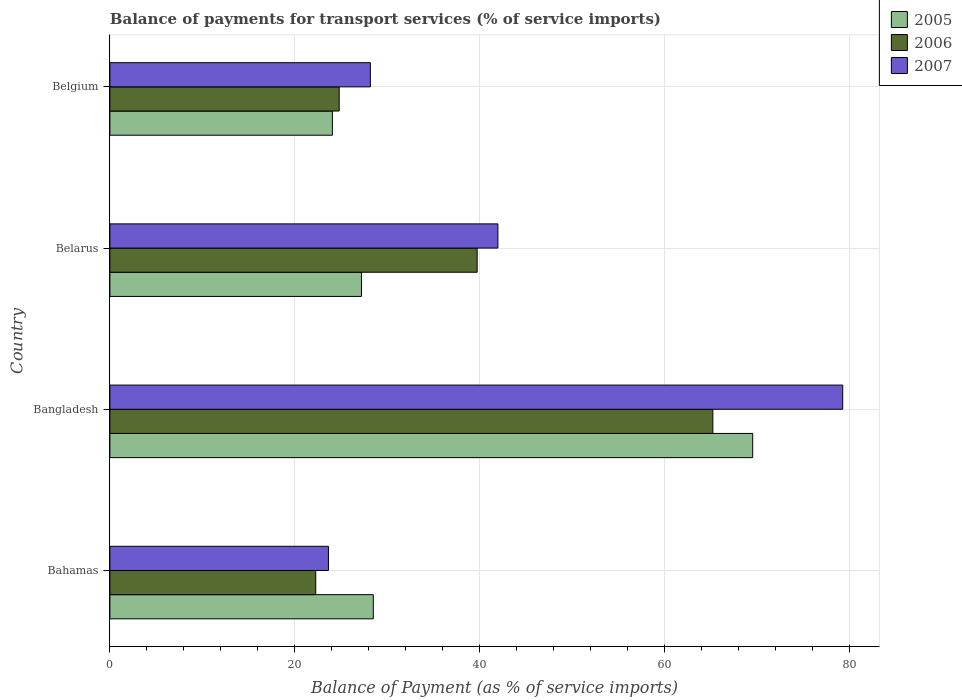How many different coloured bars are there?
Make the answer very short. 3. Are the number of bars per tick equal to the number of legend labels?
Your answer should be very brief. Yes. How many bars are there on the 2nd tick from the top?
Make the answer very short. 3. What is the label of the 4th group of bars from the top?
Keep it short and to the point. Bahamas. In how many cases, is the number of bars for a given country not equal to the number of legend labels?
Make the answer very short. 0. What is the balance of payments for transport services in 2006 in Bahamas?
Ensure brevity in your answer.  22.26. Across all countries, what is the maximum balance of payments for transport services in 2006?
Provide a succinct answer. 65.2. Across all countries, what is the minimum balance of payments for transport services in 2006?
Provide a succinct answer. 22.26. In which country was the balance of payments for transport services in 2005 maximum?
Provide a succinct answer. Bangladesh. In which country was the balance of payments for transport services in 2005 minimum?
Offer a very short reply. Belgium. What is the total balance of payments for transport services in 2007 in the graph?
Provide a short and direct response. 172.99. What is the difference between the balance of payments for transport services in 2006 in Bangladesh and that in Belarus?
Provide a succinct answer. 25.48. What is the difference between the balance of payments for transport services in 2005 in Bangladesh and the balance of payments for transport services in 2007 in Belarus?
Provide a succinct answer. 27.55. What is the average balance of payments for transport services in 2007 per country?
Make the answer very short. 43.25. What is the difference between the balance of payments for transport services in 2007 and balance of payments for transport services in 2006 in Belarus?
Give a very brief answer. 2.24. What is the ratio of the balance of payments for transport services in 2007 in Bahamas to that in Belarus?
Your response must be concise. 0.56. Is the difference between the balance of payments for transport services in 2007 in Belarus and Belgium greater than the difference between the balance of payments for transport services in 2006 in Belarus and Belgium?
Keep it short and to the point. No. What is the difference between the highest and the second highest balance of payments for transport services in 2005?
Ensure brevity in your answer.  41.02. What is the difference between the highest and the lowest balance of payments for transport services in 2006?
Your response must be concise. 42.94. Is the sum of the balance of payments for transport services in 2007 in Bahamas and Belarus greater than the maximum balance of payments for transport services in 2006 across all countries?
Provide a succinct answer. Yes. Is it the case that in every country, the sum of the balance of payments for transport services in 2005 and balance of payments for transport services in 2007 is greater than the balance of payments for transport services in 2006?
Make the answer very short. Yes. How many bars are there?
Your answer should be compact. 12. Are all the bars in the graph horizontal?
Offer a terse response. Yes. How many countries are there in the graph?
Offer a very short reply. 4. What is the difference between two consecutive major ticks on the X-axis?
Provide a short and direct response. 20. Are the values on the major ticks of X-axis written in scientific E-notation?
Keep it short and to the point. No. Does the graph contain any zero values?
Your response must be concise. No. Where does the legend appear in the graph?
Your response must be concise. Top right. How many legend labels are there?
Offer a terse response. 3. What is the title of the graph?
Your answer should be very brief. Balance of payments for transport services (% of service imports). What is the label or title of the X-axis?
Offer a terse response. Balance of Payment (as % of service imports). What is the Balance of Payment (as % of service imports) in 2005 in Bahamas?
Give a very brief answer. 28.48. What is the Balance of Payment (as % of service imports) in 2006 in Bahamas?
Make the answer very short. 22.26. What is the Balance of Payment (as % of service imports) of 2007 in Bahamas?
Your answer should be very brief. 23.63. What is the Balance of Payment (as % of service imports) of 2005 in Bangladesh?
Your answer should be compact. 69.5. What is the Balance of Payment (as % of service imports) in 2006 in Bangladesh?
Your answer should be very brief. 65.2. What is the Balance of Payment (as % of service imports) of 2007 in Bangladesh?
Your answer should be very brief. 79.24. What is the Balance of Payment (as % of service imports) of 2005 in Belarus?
Make the answer very short. 27.2. What is the Balance of Payment (as % of service imports) in 2006 in Belarus?
Ensure brevity in your answer.  39.71. What is the Balance of Payment (as % of service imports) of 2007 in Belarus?
Offer a very short reply. 41.96. What is the Balance of Payment (as % of service imports) in 2005 in Belgium?
Offer a very short reply. 24.06. What is the Balance of Payment (as % of service imports) in 2006 in Belgium?
Provide a short and direct response. 24.79. What is the Balance of Payment (as % of service imports) of 2007 in Belgium?
Your response must be concise. 28.16. Across all countries, what is the maximum Balance of Payment (as % of service imports) in 2005?
Your response must be concise. 69.5. Across all countries, what is the maximum Balance of Payment (as % of service imports) of 2006?
Your response must be concise. 65.2. Across all countries, what is the maximum Balance of Payment (as % of service imports) in 2007?
Give a very brief answer. 79.24. Across all countries, what is the minimum Balance of Payment (as % of service imports) in 2005?
Ensure brevity in your answer.  24.06. Across all countries, what is the minimum Balance of Payment (as % of service imports) of 2006?
Make the answer very short. 22.26. Across all countries, what is the minimum Balance of Payment (as % of service imports) of 2007?
Offer a very short reply. 23.63. What is the total Balance of Payment (as % of service imports) of 2005 in the graph?
Offer a very short reply. 149.25. What is the total Balance of Payment (as % of service imports) of 2006 in the graph?
Ensure brevity in your answer.  151.96. What is the total Balance of Payment (as % of service imports) of 2007 in the graph?
Offer a terse response. 172.99. What is the difference between the Balance of Payment (as % of service imports) of 2005 in Bahamas and that in Bangladesh?
Provide a succinct answer. -41.02. What is the difference between the Balance of Payment (as % of service imports) in 2006 in Bahamas and that in Bangladesh?
Offer a very short reply. -42.94. What is the difference between the Balance of Payment (as % of service imports) in 2007 in Bahamas and that in Bangladesh?
Your answer should be very brief. -55.61. What is the difference between the Balance of Payment (as % of service imports) in 2005 in Bahamas and that in Belarus?
Keep it short and to the point. 1.28. What is the difference between the Balance of Payment (as % of service imports) in 2006 in Bahamas and that in Belarus?
Your response must be concise. -17.45. What is the difference between the Balance of Payment (as % of service imports) of 2007 in Bahamas and that in Belarus?
Offer a terse response. -18.32. What is the difference between the Balance of Payment (as % of service imports) in 2005 in Bahamas and that in Belgium?
Give a very brief answer. 4.42. What is the difference between the Balance of Payment (as % of service imports) in 2006 in Bahamas and that in Belgium?
Your answer should be very brief. -2.54. What is the difference between the Balance of Payment (as % of service imports) of 2007 in Bahamas and that in Belgium?
Keep it short and to the point. -4.53. What is the difference between the Balance of Payment (as % of service imports) in 2005 in Bangladesh and that in Belarus?
Your answer should be very brief. 42.3. What is the difference between the Balance of Payment (as % of service imports) of 2006 in Bangladesh and that in Belarus?
Give a very brief answer. 25.48. What is the difference between the Balance of Payment (as % of service imports) of 2007 in Bangladesh and that in Belarus?
Provide a succinct answer. 37.28. What is the difference between the Balance of Payment (as % of service imports) in 2005 in Bangladesh and that in Belgium?
Give a very brief answer. 45.45. What is the difference between the Balance of Payment (as % of service imports) in 2006 in Bangladesh and that in Belgium?
Your response must be concise. 40.4. What is the difference between the Balance of Payment (as % of service imports) of 2007 in Bangladesh and that in Belgium?
Keep it short and to the point. 51.08. What is the difference between the Balance of Payment (as % of service imports) of 2005 in Belarus and that in Belgium?
Offer a terse response. 3.15. What is the difference between the Balance of Payment (as % of service imports) of 2006 in Belarus and that in Belgium?
Offer a terse response. 14.92. What is the difference between the Balance of Payment (as % of service imports) of 2007 in Belarus and that in Belgium?
Offer a terse response. 13.79. What is the difference between the Balance of Payment (as % of service imports) in 2005 in Bahamas and the Balance of Payment (as % of service imports) in 2006 in Bangladesh?
Your answer should be very brief. -36.71. What is the difference between the Balance of Payment (as % of service imports) in 2005 in Bahamas and the Balance of Payment (as % of service imports) in 2007 in Bangladesh?
Your response must be concise. -50.76. What is the difference between the Balance of Payment (as % of service imports) of 2006 in Bahamas and the Balance of Payment (as % of service imports) of 2007 in Bangladesh?
Your answer should be very brief. -56.98. What is the difference between the Balance of Payment (as % of service imports) of 2005 in Bahamas and the Balance of Payment (as % of service imports) of 2006 in Belarus?
Your response must be concise. -11.23. What is the difference between the Balance of Payment (as % of service imports) in 2005 in Bahamas and the Balance of Payment (as % of service imports) in 2007 in Belarus?
Your response must be concise. -13.47. What is the difference between the Balance of Payment (as % of service imports) in 2006 in Bahamas and the Balance of Payment (as % of service imports) in 2007 in Belarus?
Provide a succinct answer. -19.7. What is the difference between the Balance of Payment (as % of service imports) of 2005 in Bahamas and the Balance of Payment (as % of service imports) of 2006 in Belgium?
Keep it short and to the point. 3.69. What is the difference between the Balance of Payment (as % of service imports) of 2005 in Bahamas and the Balance of Payment (as % of service imports) of 2007 in Belgium?
Provide a short and direct response. 0.32. What is the difference between the Balance of Payment (as % of service imports) of 2006 in Bahamas and the Balance of Payment (as % of service imports) of 2007 in Belgium?
Provide a short and direct response. -5.91. What is the difference between the Balance of Payment (as % of service imports) of 2005 in Bangladesh and the Balance of Payment (as % of service imports) of 2006 in Belarus?
Keep it short and to the point. 29.79. What is the difference between the Balance of Payment (as % of service imports) of 2005 in Bangladesh and the Balance of Payment (as % of service imports) of 2007 in Belarus?
Give a very brief answer. 27.55. What is the difference between the Balance of Payment (as % of service imports) in 2006 in Bangladesh and the Balance of Payment (as % of service imports) in 2007 in Belarus?
Make the answer very short. 23.24. What is the difference between the Balance of Payment (as % of service imports) in 2005 in Bangladesh and the Balance of Payment (as % of service imports) in 2006 in Belgium?
Your answer should be very brief. 44.71. What is the difference between the Balance of Payment (as % of service imports) in 2005 in Bangladesh and the Balance of Payment (as % of service imports) in 2007 in Belgium?
Your answer should be compact. 41.34. What is the difference between the Balance of Payment (as % of service imports) of 2006 in Bangladesh and the Balance of Payment (as % of service imports) of 2007 in Belgium?
Keep it short and to the point. 37.03. What is the difference between the Balance of Payment (as % of service imports) of 2005 in Belarus and the Balance of Payment (as % of service imports) of 2006 in Belgium?
Your response must be concise. 2.41. What is the difference between the Balance of Payment (as % of service imports) in 2005 in Belarus and the Balance of Payment (as % of service imports) in 2007 in Belgium?
Make the answer very short. -0.96. What is the difference between the Balance of Payment (as % of service imports) in 2006 in Belarus and the Balance of Payment (as % of service imports) in 2007 in Belgium?
Offer a very short reply. 11.55. What is the average Balance of Payment (as % of service imports) in 2005 per country?
Keep it short and to the point. 37.31. What is the average Balance of Payment (as % of service imports) in 2006 per country?
Give a very brief answer. 37.99. What is the average Balance of Payment (as % of service imports) in 2007 per country?
Make the answer very short. 43.25. What is the difference between the Balance of Payment (as % of service imports) of 2005 and Balance of Payment (as % of service imports) of 2006 in Bahamas?
Offer a very short reply. 6.22. What is the difference between the Balance of Payment (as % of service imports) of 2005 and Balance of Payment (as % of service imports) of 2007 in Bahamas?
Ensure brevity in your answer.  4.85. What is the difference between the Balance of Payment (as % of service imports) of 2006 and Balance of Payment (as % of service imports) of 2007 in Bahamas?
Provide a succinct answer. -1.37. What is the difference between the Balance of Payment (as % of service imports) in 2005 and Balance of Payment (as % of service imports) in 2006 in Bangladesh?
Offer a terse response. 4.31. What is the difference between the Balance of Payment (as % of service imports) in 2005 and Balance of Payment (as % of service imports) in 2007 in Bangladesh?
Offer a terse response. -9.74. What is the difference between the Balance of Payment (as % of service imports) of 2006 and Balance of Payment (as % of service imports) of 2007 in Bangladesh?
Give a very brief answer. -14.04. What is the difference between the Balance of Payment (as % of service imports) in 2005 and Balance of Payment (as % of service imports) in 2006 in Belarus?
Keep it short and to the point. -12.51. What is the difference between the Balance of Payment (as % of service imports) in 2005 and Balance of Payment (as % of service imports) in 2007 in Belarus?
Your answer should be very brief. -14.75. What is the difference between the Balance of Payment (as % of service imports) of 2006 and Balance of Payment (as % of service imports) of 2007 in Belarus?
Provide a short and direct response. -2.24. What is the difference between the Balance of Payment (as % of service imports) of 2005 and Balance of Payment (as % of service imports) of 2006 in Belgium?
Your answer should be compact. -0.74. What is the difference between the Balance of Payment (as % of service imports) of 2005 and Balance of Payment (as % of service imports) of 2007 in Belgium?
Give a very brief answer. -4.11. What is the difference between the Balance of Payment (as % of service imports) in 2006 and Balance of Payment (as % of service imports) in 2007 in Belgium?
Your answer should be compact. -3.37. What is the ratio of the Balance of Payment (as % of service imports) in 2005 in Bahamas to that in Bangladesh?
Make the answer very short. 0.41. What is the ratio of the Balance of Payment (as % of service imports) in 2006 in Bahamas to that in Bangladesh?
Provide a short and direct response. 0.34. What is the ratio of the Balance of Payment (as % of service imports) in 2007 in Bahamas to that in Bangladesh?
Your response must be concise. 0.3. What is the ratio of the Balance of Payment (as % of service imports) in 2005 in Bahamas to that in Belarus?
Your answer should be very brief. 1.05. What is the ratio of the Balance of Payment (as % of service imports) of 2006 in Bahamas to that in Belarus?
Keep it short and to the point. 0.56. What is the ratio of the Balance of Payment (as % of service imports) of 2007 in Bahamas to that in Belarus?
Your answer should be very brief. 0.56. What is the ratio of the Balance of Payment (as % of service imports) of 2005 in Bahamas to that in Belgium?
Give a very brief answer. 1.18. What is the ratio of the Balance of Payment (as % of service imports) of 2006 in Bahamas to that in Belgium?
Your answer should be very brief. 0.9. What is the ratio of the Balance of Payment (as % of service imports) in 2007 in Bahamas to that in Belgium?
Keep it short and to the point. 0.84. What is the ratio of the Balance of Payment (as % of service imports) in 2005 in Bangladesh to that in Belarus?
Your answer should be compact. 2.55. What is the ratio of the Balance of Payment (as % of service imports) in 2006 in Bangladesh to that in Belarus?
Keep it short and to the point. 1.64. What is the ratio of the Balance of Payment (as % of service imports) of 2007 in Bangladesh to that in Belarus?
Your answer should be compact. 1.89. What is the ratio of the Balance of Payment (as % of service imports) of 2005 in Bangladesh to that in Belgium?
Offer a very short reply. 2.89. What is the ratio of the Balance of Payment (as % of service imports) in 2006 in Bangladesh to that in Belgium?
Keep it short and to the point. 2.63. What is the ratio of the Balance of Payment (as % of service imports) in 2007 in Bangladesh to that in Belgium?
Provide a short and direct response. 2.81. What is the ratio of the Balance of Payment (as % of service imports) of 2005 in Belarus to that in Belgium?
Keep it short and to the point. 1.13. What is the ratio of the Balance of Payment (as % of service imports) in 2006 in Belarus to that in Belgium?
Make the answer very short. 1.6. What is the ratio of the Balance of Payment (as % of service imports) in 2007 in Belarus to that in Belgium?
Provide a short and direct response. 1.49. What is the difference between the highest and the second highest Balance of Payment (as % of service imports) in 2005?
Provide a short and direct response. 41.02. What is the difference between the highest and the second highest Balance of Payment (as % of service imports) of 2006?
Give a very brief answer. 25.48. What is the difference between the highest and the second highest Balance of Payment (as % of service imports) of 2007?
Keep it short and to the point. 37.28. What is the difference between the highest and the lowest Balance of Payment (as % of service imports) of 2005?
Ensure brevity in your answer.  45.45. What is the difference between the highest and the lowest Balance of Payment (as % of service imports) of 2006?
Make the answer very short. 42.94. What is the difference between the highest and the lowest Balance of Payment (as % of service imports) of 2007?
Make the answer very short. 55.61. 